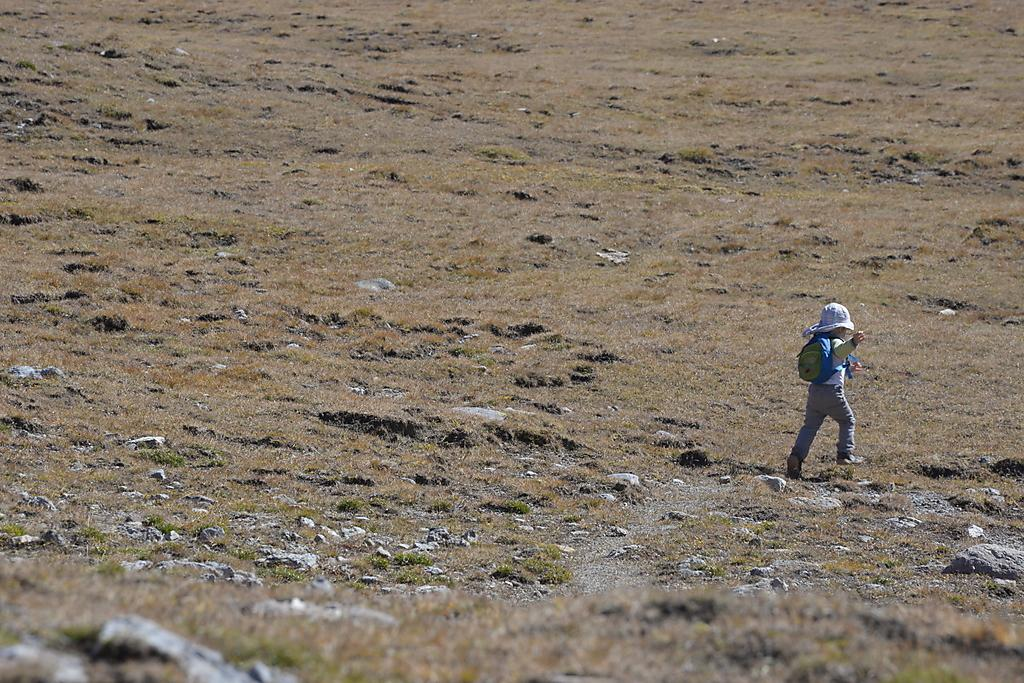What is the main subject of the image? The main subject of the image is a kid. What is the kid doing in the image? The kid is running on the ground. What is the kid carrying while running? The kid is carrying a bag on their shoulders. What is the kid wearing on their head? The kid is wearing a hat. What type of terrain is visible in the image? There is grass and stones on the ground. How many snails can be seen crawling on the hat in the image? There are no snails visible in the image, and the hat is not mentioned as having any snails on it. 